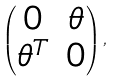Convert formula to latex. <formula><loc_0><loc_0><loc_500><loc_500>\begin{pmatrix} 0 & \theta \\ \theta ^ { T } & 0 \end{pmatrix} ,</formula> 